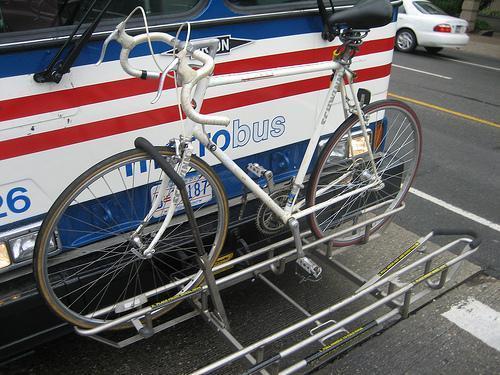How many bikes will fit on rack?
Give a very brief answer. 2. 